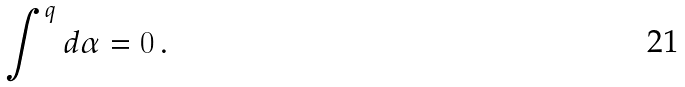Convert formula to latex. <formula><loc_0><loc_0><loc_500><loc_500>\int ^ { q } d \alpha = 0 \, .</formula> 